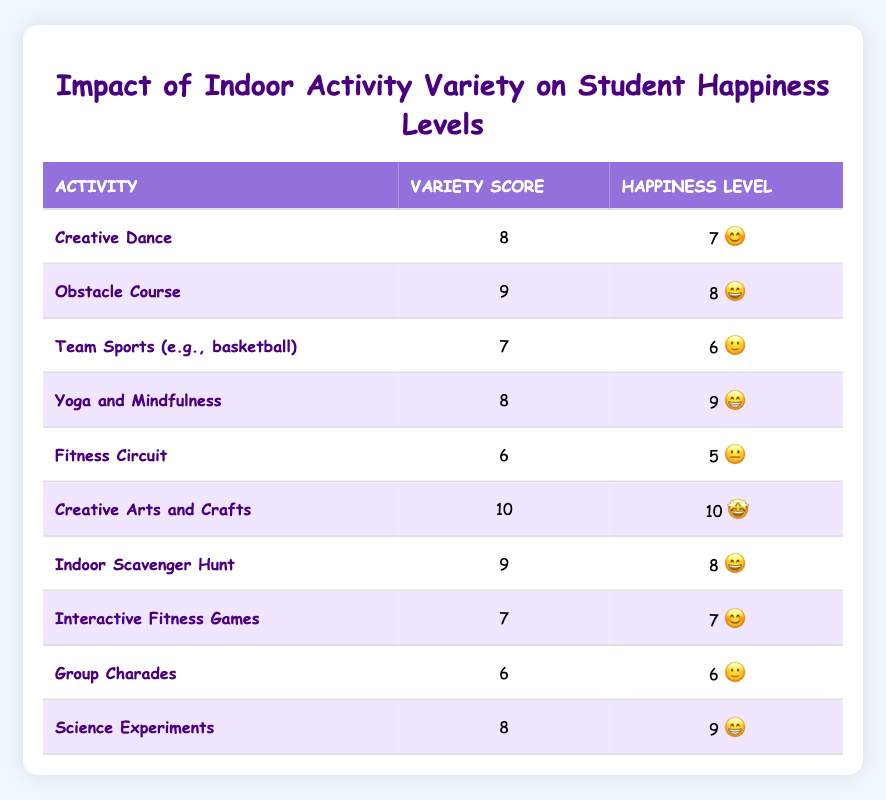What is the variety score for Creative Dance? The table lists "Creative Dance" with a variety score of 8 in the corresponding column.
Answer: 8 Which activity has the highest happiness level? By examining the happiness level column, "Creative Arts and Crafts" has the highest score of 10.
Answer: Creative Arts and Crafts Is the happiness level for Fitness Circuit above 5? The happiness level for "Fitness Circuit" is listed as 5, which means it is not above 5.
Answer: No What is the average variety score of all activities? We sum the variety scores: 8 + 9 + 7 + 8 + 6 + 10 + 9 + 7 + 6 + 8 = 78. There are 10 activities, so the average is 78/10 = 7.8.
Answer: 7.8 How many activities have a variety score of 9 or higher? The activities with scores 9 or higher are "Obstacle Course," "Creative Arts and Crafts," "Indoor Scavenger Hunt," and "Yoga and Mindfulness." That is 4 activities in total.
Answer: 4 Is there an activity with both a score of 6 and a happiness level of 6? Yes, "Team Sports (e.g., basketball)" and "Group Charades" both have a variety score of 6 and a happiness level of 6 each.
Answer: Yes What is the difference between the highest and lowest happiness levels? The highest happiness level is 10 (Creative Arts and Crafts) and the lowest is 5 (Fitness Circuit), so the difference is 10 - 5 = 5.
Answer: 5 Which activity would most likely bring the most excitement, based on the happiness level? "Creative Arts and Crafts" shows the highest happiness level of 10, indicating it would bring the most excitement.
Answer: Creative Arts and Crafts How many activities scored 8 or higher in happiness levels? Looking at the happiness level column, the activities with scores of 8 or higher are "Yoga and Mindfulness," "Creative Arts and Crafts," "Indoor Scavenger Hunt," and "Science Experiments," totaling 4 activities.
Answer: 4 